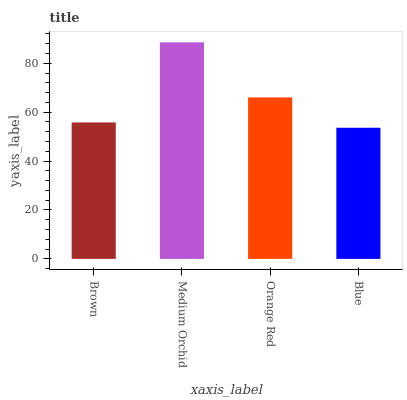Is Orange Red the minimum?
Answer yes or no. No. Is Orange Red the maximum?
Answer yes or no. No. Is Medium Orchid greater than Orange Red?
Answer yes or no. Yes. Is Orange Red less than Medium Orchid?
Answer yes or no. Yes. Is Orange Red greater than Medium Orchid?
Answer yes or no. No. Is Medium Orchid less than Orange Red?
Answer yes or no. No. Is Orange Red the high median?
Answer yes or no. Yes. Is Brown the low median?
Answer yes or no. Yes. Is Brown the high median?
Answer yes or no. No. Is Orange Red the low median?
Answer yes or no. No. 